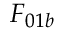<formula> <loc_0><loc_0><loc_500><loc_500>F _ { 0 1 b }</formula> 